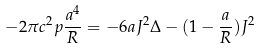<formula> <loc_0><loc_0><loc_500><loc_500>- 2 { \pi } c ^ { 2 } p \frac { a ^ { 4 } } { R } = - 6 a J ^ { 2 } { \Delta } - ( 1 - \frac { a } { R } ) J ^ { 2 }</formula> 